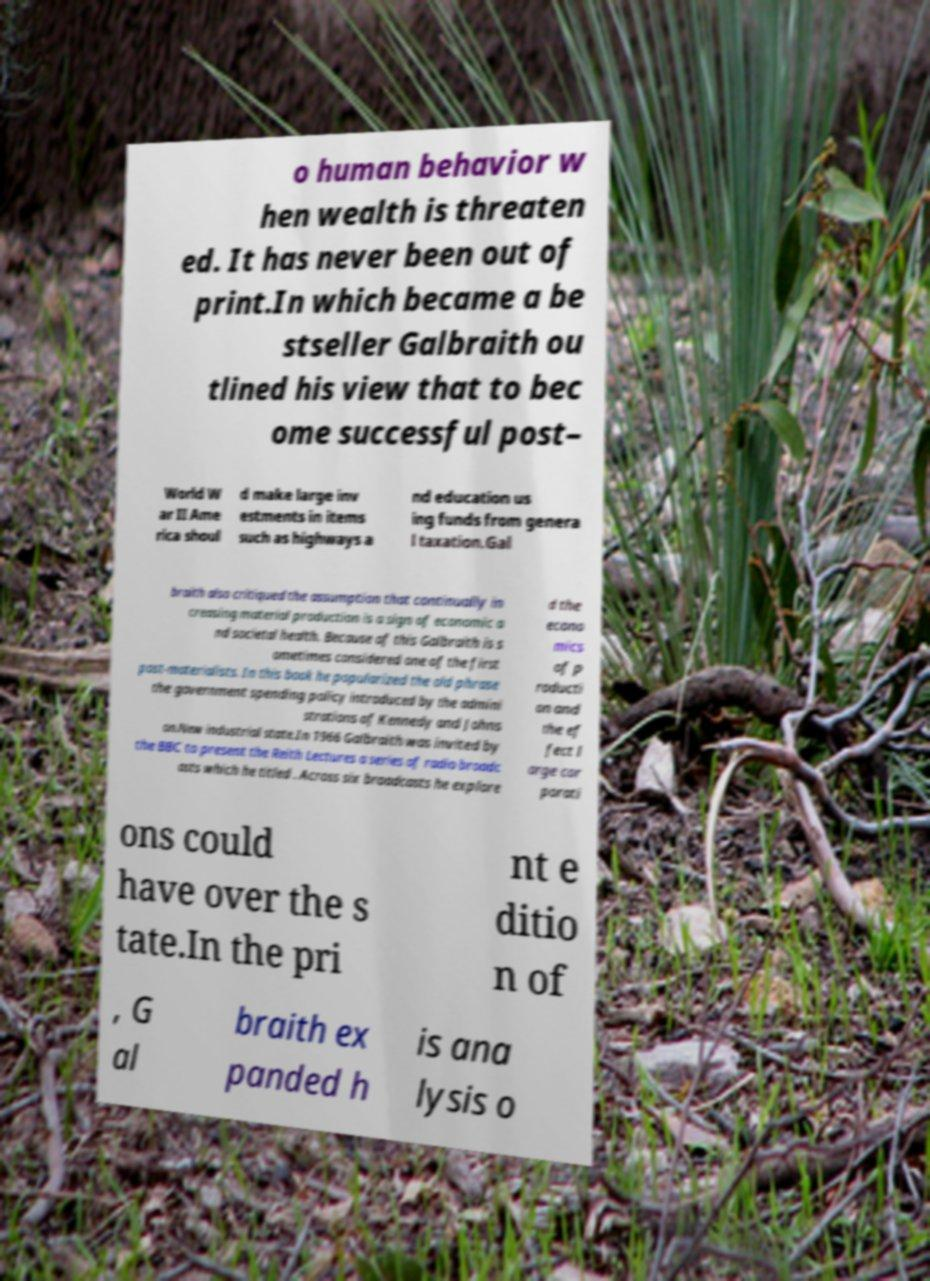What messages or text are displayed in this image? I need them in a readable, typed format. o human behavior w hen wealth is threaten ed. It has never been out of print.In which became a be stseller Galbraith ou tlined his view that to bec ome successful post– World W ar II Ame rica shoul d make large inv estments in items such as highways a nd education us ing funds from genera l taxation.Gal braith also critiqued the assumption that continually in creasing material production is a sign of economic a nd societal health. Because of this Galbraith is s ometimes considered one of the first post-materialists. In this book he popularized the old phrase the government spending policy introduced by the admini strations of Kennedy and Johns on.New industrial state.In 1966 Galbraith was invited by the BBC to present the Reith Lectures a series of radio broadc asts which he titled . Across six broadcasts he explore d the econo mics of p roducti on and the ef fect l arge cor porati ons could have over the s tate.In the pri nt e ditio n of , G al braith ex panded h is ana lysis o 